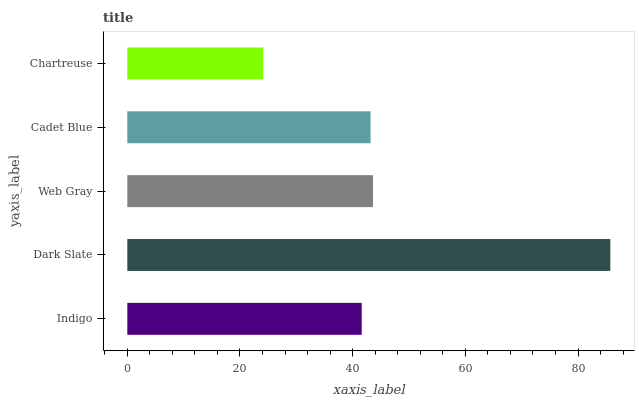Is Chartreuse the minimum?
Answer yes or no. Yes. Is Dark Slate the maximum?
Answer yes or no. Yes. Is Web Gray the minimum?
Answer yes or no. No. Is Web Gray the maximum?
Answer yes or no. No. Is Dark Slate greater than Web Gray?
Answer yes or no. Yes. Is Web Gray less than Dark Slate?
Answer yes or no. Yes. Is Web Gray greater than Dark Slate?
Answer yes or no. No. Is Dark Slate less than Web Gray?
Answer yes or no. No. Is Cadet Blue the high median?
Answer yes or no. Yes. Is Cadet Blue the low median?
Answer yes or no. Yes. Is Dark Slate the high median?
Answer yes or no. No. Is Chartreuse the low median?
Answer yes or no. No. 